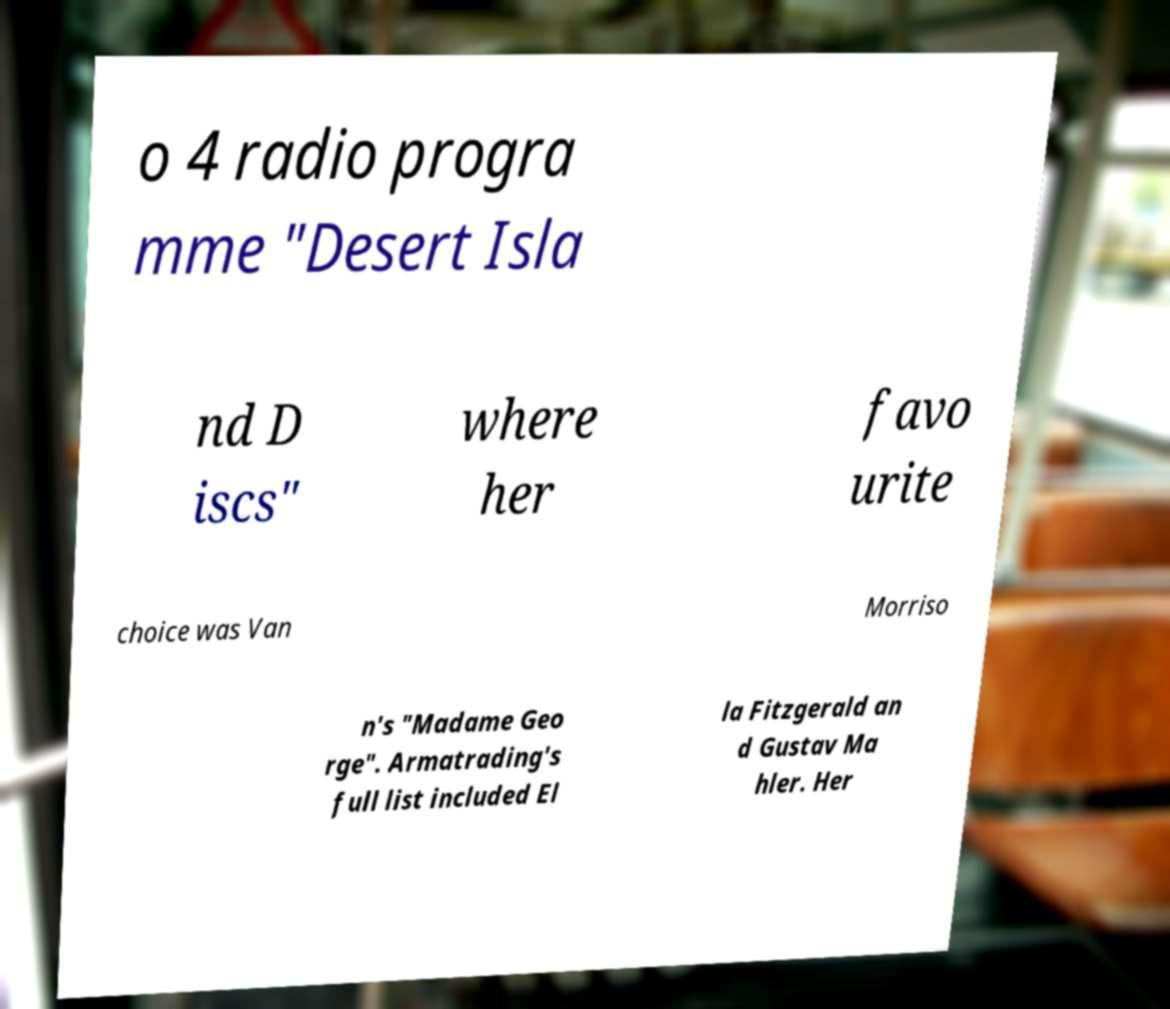Can you accurately transcribe the text from the provided image for me? o 4 radio progra mme "Desert Isla nd D iscs" where her favo urite choice was Van Morriso n's "Madame Geo rge". Armatrading's full list included El la Fitzgerald an d Gustav Ma hler. Her 